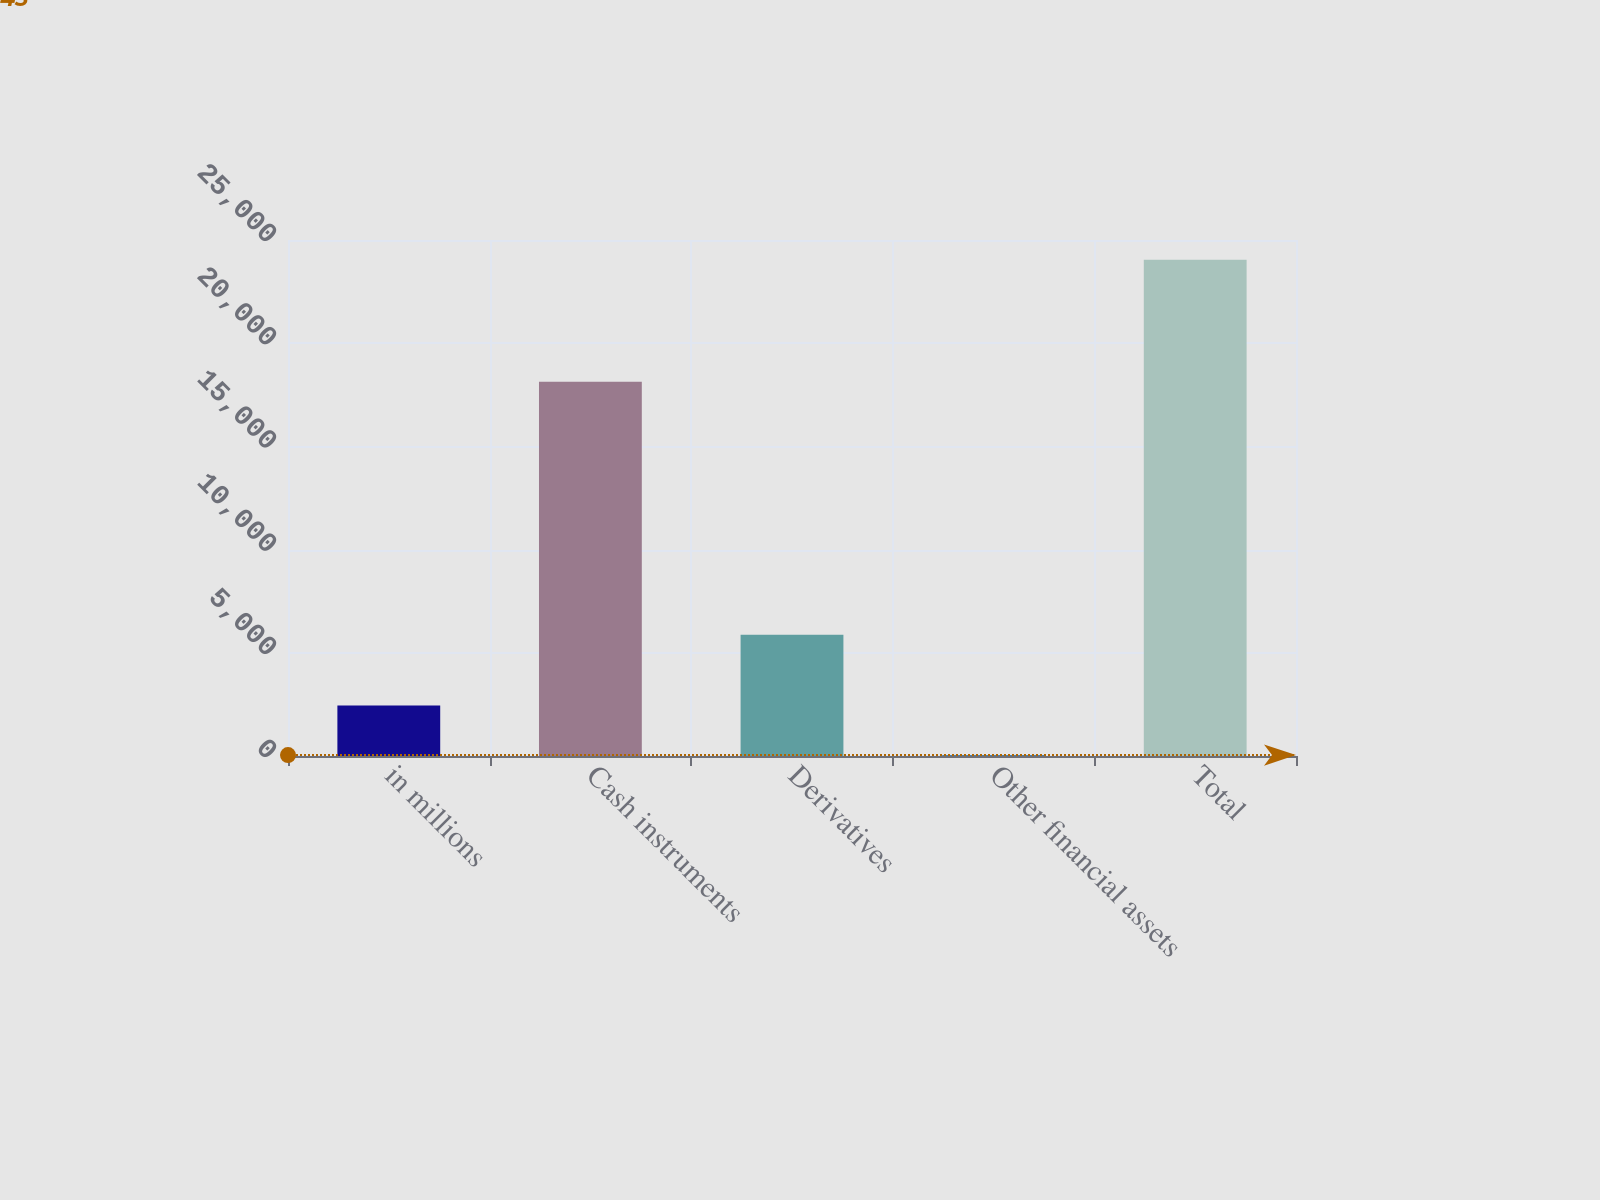Convert chart to OTSL. <chart><loc_0><loc_0><loc_500><loc_500><bar_chart><fcel>in millions<fcel>Cash instruments<fcel>Derivatives<fcel>Other financial assets<fcel>Total<nl><fcel>2445.1<fcel>18131<fcel>5870<fcel>45<fcel>24046<nl></chart> 